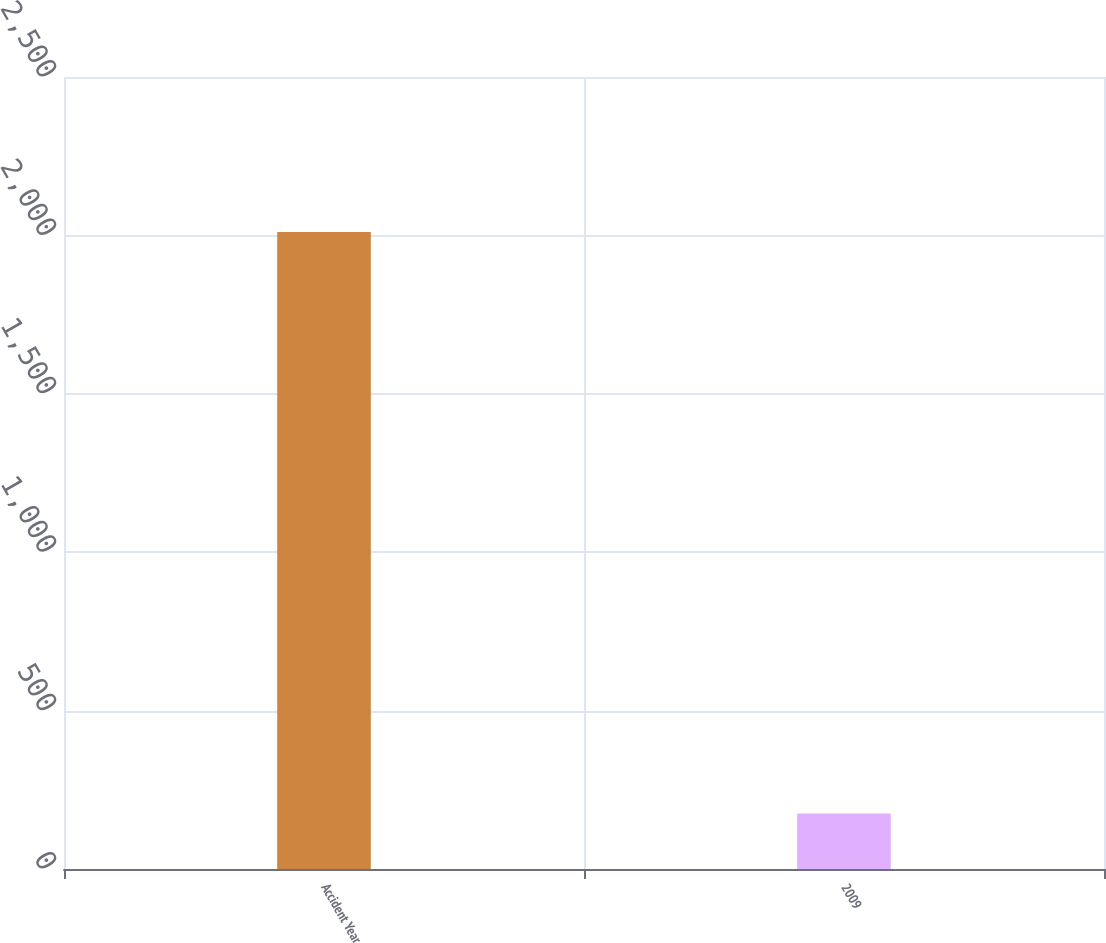Convert chart to OTSL. <chart><loc_0><loc_0><loc_500><loc_500><bar_chart><fcel>Accident Year<fcel>2009<nl><fcel>2011<fcel>175<nl></chart> 